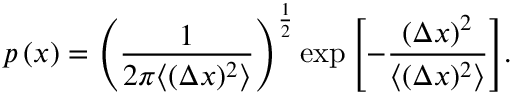Convert formula to latex. <formula><loc_0><loc_0><loc_500><loc_500>p \left ( x \right ) = \left ( \frac { 1 } { 2 \pi \langle ( \Delta x ) ^ { 2 } \rangle } \right ) ^ { \frac { 1 } { 2 } } \exp { \left [ - \frac { ( \Delta x ) ^ { 2 } } { \langle ( \Delta x ) ^ { 2 } \rangle } \right ] } .</formula> 